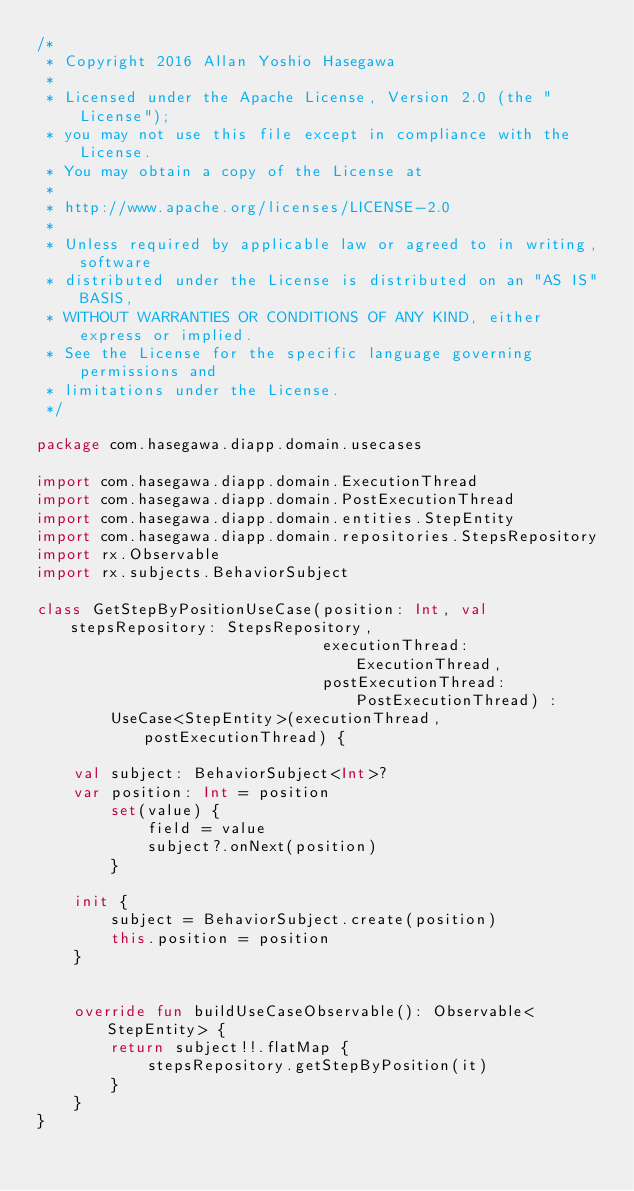<code> <loc_0><loc_0><loc_500><loc_500><_Kotlin_>/*
 * Copyright 2016 Allan Yoshio Hasegawa
 *
 * Licensed under the Apache License, Version 2.0 (the "License");
 * you may not use this file except in compliance with the License.
 * You may obtain a copy of the License at
 *
 * http://www.apache.org/licenses/LICENSE-2.0
 *
 * Unless required by applicable law or agreed to in writing, software
 * distributed under the License is distributed on an "AS IS" BASIS,
 * WITHOUT WARRANTIES OR CONDITIONS OF ANY KIND, either express or implied.
 * See the License for the specific language governing permissions and
 * limitations under the License.
 */

package com.hasegawa.diapp.domain.usecases

import com.hasegawa.diapp.domain.ExecutionThread
import com.hasegawa.diapp.domain.PostExecutionThread
import com.hasegawa.diapp.domain.entities.StepEntity
import com.hasegawa.diapp.domain.repositories.StepsRepository
import rx.Observable
import rx.subjects.BehaviorSubject

class GetStepByPositionUseCase(position: Int, val stepsRepository: StepsRepository,
                               executionThread: ExecutionThread,
                               postExecutionThread: PostExecutionThread) :
        UseCase<StepEntity>(executionThread, postExecutionThread) {

    val subject: BehaviorSubject<Int>?
    var position: Int = position
        set(value) {
            field = value
            subject?.onNext(position)
        }

    init {
        subject = BehaviorSubject.create(position)
        this.position = position
    }


    override fun buildUseCaseObservable(): Observable<StepEntity> {
        return subject!!.flatMap {
            stepsRepository.getStepByPosition(it)
        }
    }
}
</code> 